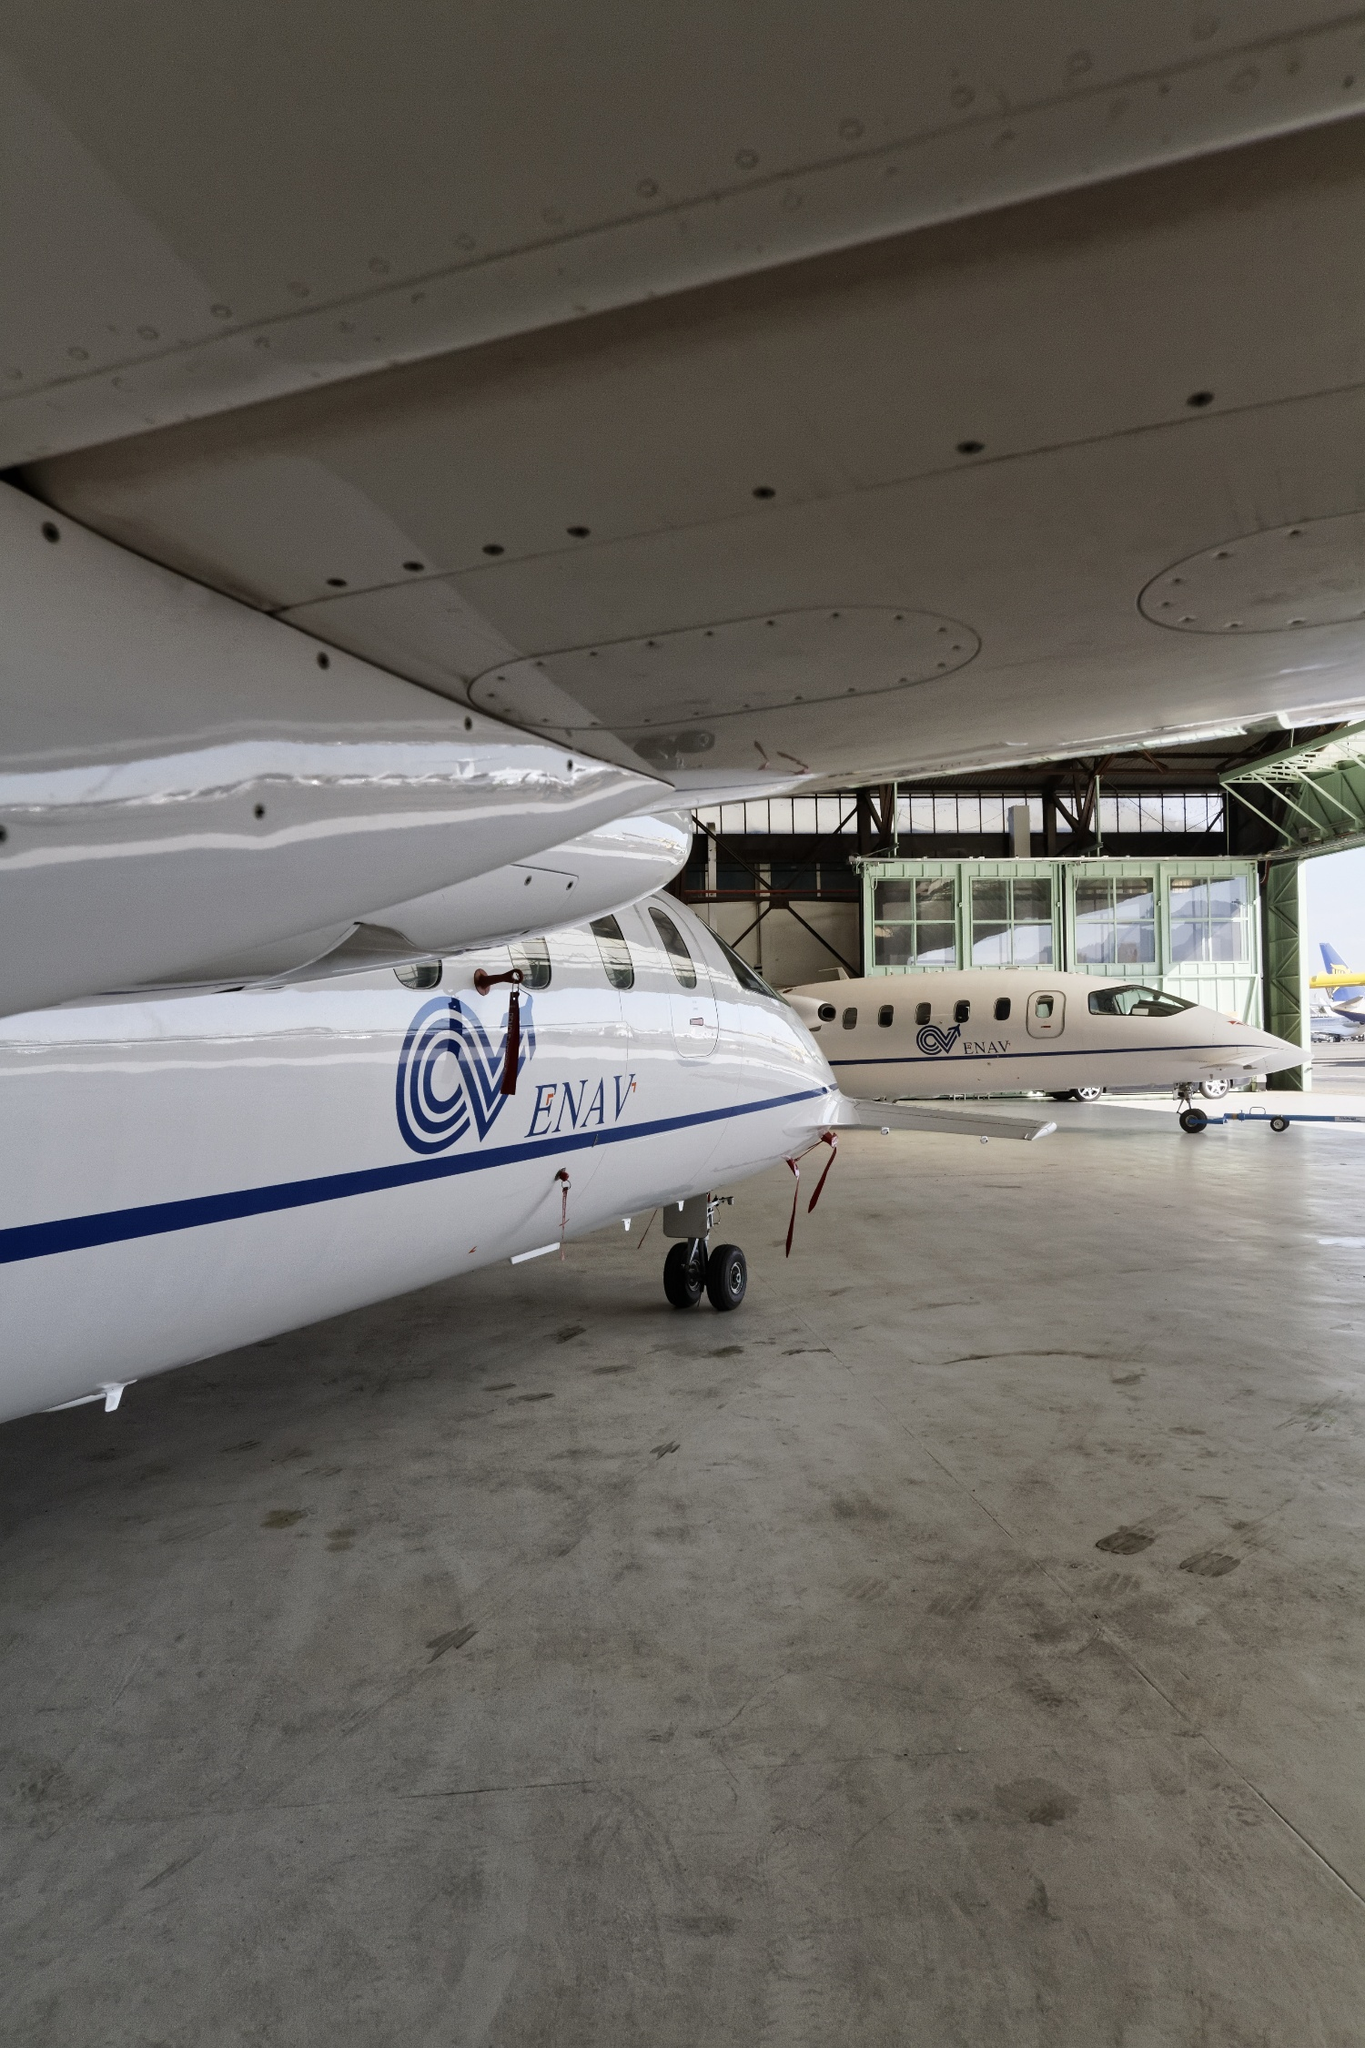What can you tell me about these airplanes? The airplanes in the image are modern aircraft likely used for either commercial or private purposes. The first plane, with the ENAV logo, is painted predominantly in white with blue and red accents. ENAV typically indicates a connection with air navigation services in some regions. The second plane, sitting further back in the hangar, also sports a sleek white design with gray and blue details. These planes are housed within a concrete hangar that is well-lit by natural light from the windows above. The hangar is spacious and organized, suggesting a professional and operational environment focused on aviation tasks such as maintenance or preparation for flights. Imagine these airplanes could talk. What kind of conversation would they have? Plane 1: 'It's been quite a restful period here in the hangar, hasn't it?' Plane 2: 'Indeed, though I'm always itching to soar through the skies again. The view from up there is unparalleled!' Plane 1: 'I agree. It's fascinating how we can travel thousands of miles, crossing continents. What was your last journey like?' Plane 2: 'Oh, it was splendid! I flew over the Alps; the snowy peaks were breathtaking. And you?' Plane 1: 'I had a rather calm flight along the Mediterranean coast. The ocean was a radiant blue, shimmering in the sunlight.' Plane 2: 'Here's to hoping our next adventures come soon. There's always a certain thrill to hear the engines start and feel the runway under our wheels again.' 